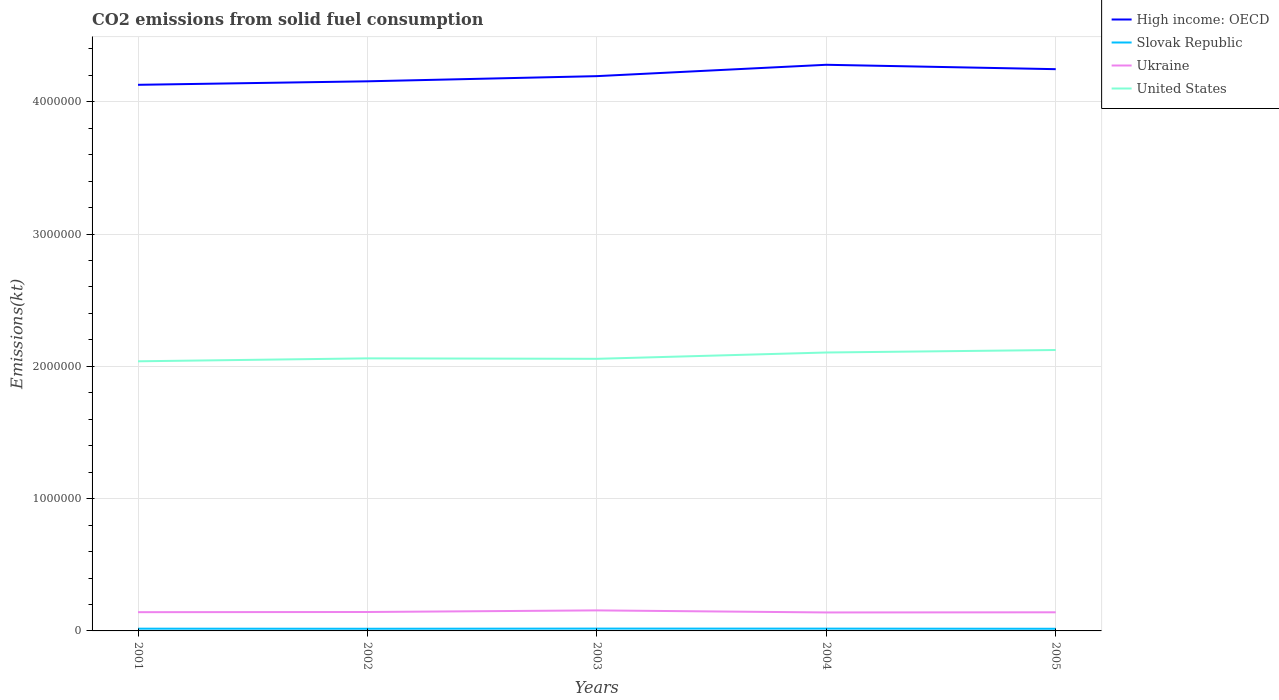Is the number of lines equal to the number of legend labels?
Give a very brief answer. Yes. Across all years, what is the maximum amount of CO2 emitted in Slovak Republic?
Your response must be concise. 1.63e+04. What is the total amount of CO2 emitted in High income: OECD in the graph?
Give a very brief answer. -2.64e+04. What is the difference between the highest and the second highest amount of CO2 emitted in Slovak Republic?
Ensure brevity in your answer.  1305.45. What is the difference between the highest and the lowest amount of CO2 emitted in Ukraine?
Make the answer very short. 1. Is the amount of CO2 emitted in United States strictly greater than the amount of CO2 emitted in Slovak Republic over the years?
Your answer should be compact. No. How many years are there in the graph?
Offer a very short reply. 5. What is the difference between two consecutive major ticks on the Y-axis?
Offer a terse response. 1.00e+06. Does the graph contain grids?
Provide a succinct answer. Yes. Where does the legend appear in the graph?
Your answer should be compact. Top right. How many legend labels are there?
Your answer should be very brief. 4. What is the title of the graph?
Provide a succinct answer. CO2 emissions from solid fuel consumption. What is the label or title of the Y-axis?
Your answer should be very brief. Emissions(kt). What is the Emissions(kt) of High income: OECD in 2001?
Provide a short and direct response. 4.13e+06. What is the Emissions(kt) in Slovak Republic in 2001?
Give a very brief answer. 1.70e+04. What is the Emissions(kt) in Ukraine in 2001?
Your answer should be very brief. 1.42e+05. What is the Emissions(kt) in United States in 2001?
Your answer should be compact. 2.04e+06. What is the Emissions(kt) in High income: OECD in 2002?
Your answer should be compact. 4.15e+06. What is the Emissions(kt) in Slovak Republic in 2002?
Offer a very short reply. 1.64e+04. What is the Emissions(kt) in Ukraine in 2002?
Offer a very short reply. 1.43e+05. What is the Emissions(kt) of United States in 2002?
Give a very brief answer. 2.06e+06. What is the Emissions(kt) of High income: OECD in 2003?
Make the answer very short. 4.19e+06. What is the Emissions(kt) in Slovak Republic in 2003?
Offer a very short reply. 1.76e+04. What is the Emissions(kt) of Ukraine in 2003?
Provide a succinct answer. 1.55e+05. What is the Emissions(kt) in United States in 2003?
Offer a very short reply. 2.06e+06. What is the Emissions(kt) in High income: OECD in 2004?
Your answer should be very brief. 4.28e+06. What is the Emissions(kt) in Slovak Republic in 2004?
Your response must be concise. 1.73e+04. What is the Emissions(kt) in Ukraine in 2004?
Offer a very short reply. 1.40e+05. What is the Emissions(kt) in United States in 2004?
Offer a terse response. 2.10e+06. What is the Emissions(kt) of High income: OECD in 2005?
Offer a terse response. 4.25e+06. What is the Emissions(kt) in Slovak Republic in 2005?
Your answer should be compact. 1.63e+04. What is the Emissions(kt) in Ukraine in 2005?
Provide a short and direct response. 1.41e+05. What is the Emissions(kt) of United States in 2005?
Make the answer very short. 2.12e+06. Across all years, what is the maximum Emissions(kt) of High income: OECD?
Your response must be concise. 4.28e+06. Across all years, what is the maximum Emissions(kt) of Slovak Republic?
Make the answer very short. 1.76e+04. Across all years, what is the maximum Emissions(kt) of Ukraine?
Give a very brief answer. 1.55e+05. Across all years, what is the maximum Emissions(kt) of United States?
Ensure brevity in your answer.  2.12e+06. Across all years, what is the minimum Emissions(kt) of High income: OECD?
Provide a succinct answer. 4.13e+06. Across all years, what is the minimum Emissions(kt) of Slovak Republic?
Keep it short and to the point. 1.63e+04. Across all years, what is the minimum Emissions(kt) in Ukraine?
Make the answer very short. 1.40e+05. Across all years, what is the minimum Emissions(kt) in United States?
Offer a terse response. 2.04e+06. What is the total Emissions(kt) of High income: OECD in the graph?
Make the answer very short. 2.10e+07. What is the total Emissions(kt) in Slovak Republic in the graph?
Your answer should be compact. 8.47e+04. What is the total Emissions(kt) in Ukraine in the graph?
Provide a succinct answer. 7.20e+05. What is the total Emissions(kt) in United States in the graph?
Provide a short and direct response. 1.04e+07. What is the difference between the Emissions(kt) in High income: OECD in 2001 and that in 2002?
Your answer should be compact. -2.64e+04. What is the difference between the Emissions(kt) in Slovak Republic in 2001 and that in 2002?
Provide a short and direct response. 557.38. What is the difference between the Emissions(kt) of Ukraine in 2001 and that in 2002?
Provide a short and direct response. -1279.78. What is the difference between the Emissions(kt) of United States in 2001 and that in 2002?
Provide a short and direct response. -2.22e+04. What is the difference between the Emissions(kt) in High income: OECD in 2001 and that in 2003?
Your answer should be very brief. -6.56e+04. What is the difference between the Emissions(kt) in Slovak Republic in 2001 and that in 2003?
Provide a succinct answer. -671.06. What is the difference between the Emissions(kt) of Ukraine in 2001 and that in 2003?
Your response must be concise. -1.35e+04. What is the difference between the Emissions(kt) of United States in 2001 and that in 2003?
Ensure brevity in your answer.  -1.88e+04. What is the difference between the Emissions(kt) in High income: OECD in 2001 and that in 2004?
Provide a short and direct response. -1.51e+05. What is the difference between the Emissions(kt) of Slovak Republic in 2001 and that in 2004?
Provide a succinct answer. -341.03. What is the difference between the Emissions(kt) of Ukraine in 2001 and that in 2004?
Provide a short and direct response. 2207.53. What is the difference between the Emissions(kt) of United States in 2001 and that in 2004?
Offer a terse response. -6.65e+04. What is the difference between the Emissions(kt) of High income: OECD in 2001 and that in 2005?
Your answer should be very brief. -1.18e+05. What is the difference between the Emissions(kt) of Slovak Republic in 2001 and that in 2005?
Offer a terse response. 634.39. What is the difference between the Emissions(kt) in Ukraine in 2001 and that in 2005?
Provide a succinct answer. 982.76. What is the difference between the Emissions(kt) in United States in 2001 and that in 2005?
Give a very brief answer. -8.54e+04. What is the difference between the Emissions(kt) of High income: OECD in 2002 and that in 2003?
Make the answer very short. -3.92e+04. What is the difference between the Emissions(kt) of Slovak Republic in 2002 and that in 2003?
Ensure brevity in your answer.  -1228.44. What is the difference between the Emissions(kt) in Ukraine in 2002 and that in 2003?
Keep it short and to the point. -1.22e+04. What is the difference between the Emissions(kt) of United States in 2002 and that in 2003?
Offer a very short reply. 3446.98. What is the difference between the Emissions(kt) in High income: OECD in 2002 and that in 2004?
Your answer should be very brief. -1.25e+05. What is the difference between the Emissions(kt) in Slovak Republic in 2002 and that in 2004?
Your answer should be very brief. -898.41. What is the difference between the Emissions(kt) in Ukraine in 2002 and that in 2004?
Offer a terse response. 3487.32. What is the difference between the Emissions(kt) of United States in 2002 and that in 2004?
Provide a short and direct response. -4.43e+04. What is the difference between the Emissions(kt) in High income: OECD in 2002 and that in 2005?
Offer a terse response. -9.18e+04. What is the difference between the Emissions(kt) in Slovak Republic in 2002 and that in 2005?
Provide a short and direct response. 77.01. What is the difference between the Emissions(kt) in Ukraine in 2002 and that in 2005?
Your answer should be very brief. 2262.54. What is the difference between the Emissions(kt) of United States in 2002 and that in 2005?
Offer a very short reply. -6.32e+04. What is the difference between the Emissions(kt) of High income: OECD in 2003 and that in 2004?
Give a very brief answer. -8.59e+04. What is the difference between the Emissions(kt) in Slovak Republic in 2003 and that in 2004?
Keep it short and to the point. 330.03. What is the difference between the Emissions(kt) in Ukraine in 2003 and that in 2004?
Your answer should be very brief. 1.57e+04. What is the difference between the Emissions(kt) of United States in 2003 and that in 2004?
Your response must be concise. -4.77e+04. What is the difference between the Emissions(kt) in High income: OECD in 2003 and that in 2005?
Your response must be concise. -5.26e+04. What is the difference between the Emissions(kt) of Slovak Republic in 2003 and that in 2005?
Provide a succinct answer. 1305.45. What is the difference between the Emissions(kt) of Ukraine in 2003 and that in 2005?
Offer a terse response. 1.45e+04. What is the difference between the Emissions(kt) of United States in 2003 and that in 2005?
Ensure brevity in your answer.  -6.67e+04. What is the difference between the Emissions(kt) in High income: OECD in 2004 and that in 2005?
Offer a terse response. 3.32e+04. What is the difference between the Emissions(kt) in Slovak Republic in 2004 and that in 2005?
Keep it short and to the point. 975.42. What is the difference between the Emissions(kt) of Ukraine in 2004 and that in 2005?
Offer a very short reply. -1224.78. What is the difference between the Emissions(kt) of United States in 2004 and that in 2005?
Give a very brief answer. -1.90e+04. What is the difference between the Emissions(kt) of High income: OECD in 2001 and the Emissions(kt) of Slovak Republic in 2002?
Make the answer very short. 4.11e+06. What is the difference between the Emissions(kt) in High income: OECD in 2001 and the Emissions(kt) in Ukraine in 2002?
Your response must be concise. 3.99e+06. What is the difference between the Emissions(kt) in High income: OECD in 2001 and the Emissions(kt) in United States in 2002?
Ensure brevity in your answer.  2.07e+06. What is the difference between the Emissions(kt) of Slovak Republic in 2001 and the Emissions(kt) of Ukraine in 2002?
Give a very brief answer. -1.26e+05. What is the difference between the Emissions(kt) in Slovak Republic in 2001 and the Emissions(kt) in United States in 2002?
Give a very brief answer. -2.04e+06. What is the difference between the Emissions(kt) in Ukraine in 2001 and the Emissions(kt) in United States in 2002?
Make the answer very short. -1.92e+06. What is the difference between the Emissions(kt) in High income: OECD in 2001 and the Emissions(kt) in Slovak Republic in 2003?
Your answer should be very brief. 4.11e+06. What is the difference between the Emissions(kt) in High income: OECD in 2001 and the Emissions(kt) in Ukraine in 2003?
Make the answer very short. 3.97e+06. What is the difference between the Emissions(kt) of High income: OECD in 2001 and the Emissions(kt) of United States in 2003?
Your answer should be very brief. 2.07e+06. What is the difference between the Emissions(kt) in Slovak Republic in 2001 and the Emissions(kt) in Ukraine in 2003?
Your answer should be very brief. -1.38e+05. What is the difference between the Emissions(kt) in Slovak Republic in 2001 and the Emissions(kt) in United States in 2003?
Ensure brevity in your answer.  -2.04e+06. What is the difference between the Emissions(kt) in Ukraine in 2001 and the Emissions(kt) in United States in 2003?
Ensure brevity in your answer.  -1.92e+06. What is the difference between the Emissions(kt) in High income: OECD in 2001 and the Emissions(kt) in Slovak Republic in 2004?
Give a very brief answer. 4.11e+06. What is the difference between the Emissions(kt) of High income: OECD in 2001 and the Emissions(kt) of Ukraine in 2004?
Keep it short and to the point. 3.99e+06. What is the difference between the Emissions(kt) of High income: OECD in 2001 and the Emissions(kt) of United States in 2004?
Your answer should be very brief. 2.02e+06. What is the difference between the Emissions(kt) in Slovak Republic in 2001 and the Emissions(kt) in Ukraine in 2004?
Ensure brevity in your answer.  -1.23e+05. What is the difference between the Emissions(kt) in Slovak Republic in 2001 and the Emissions(kt) in United States in 2004?
Your answer should be compact. -2.09e+06. What is the difference between the Emissions(kt) of Ukraine in 2001 and the Emissions(kt) of United States in 2004?
Give a very brief answer. -1.96e+06. What is the difference between the Emissions(kt) of High income: OECD in 2001 and the Emissions(kt) of Slovak Republic in 2005?
Make the answer very short. 4.11e+06. What is the difference between the Emissions(kt) of High income: OECD in 2001 and the Emissions(kt) of Ukraine in 2005?
Make the answer very short. 3.99e+06. What is the difference between the Emissions(kt) in High income: OECD in 2001 and the Emissions(kt) in United States in 2005?
Your answer should be very brief. 2.00e+06. What is the difference between the Emissions(kt) of Slovak Republic in 2001 and the Emissions(kt) of Ukraine in 2005?
Your answer should be compact. -1.24e+05. What is the difference between the Emissions(kt) of Slovak Republic in 2001 and the Emissions(kt) of United States in 2005?
Your answer should be very brief. -2.11e+06. What is the difference between the Emissions(kt) in Ukraine in 2001 and the Emissions(kt) in United States in 2005?
Offer a very short reply. -1.98e+06. What is the difference between the Emissions(kt) of High income: OECD in 2002 and the Emissions(kt) of Slovak Republic in 2003?
Your answer should be compact. 4.14e+06. What is the difference between the Emissions(kt) in High income: OECD in 2002 and the Emissions(kt) in Ukraine in 2003?
Give a very brief answer. 4.00e+06. What is the difference between the Emissions(kt) in High income: OECD in 2002 and the Emissions(kt) in United States in 2003?
Provide a short and direct response. 2.10e+06. What is the difference between the Emissions(kt) of Slovak Republic in 2002 and the Emissions(kt) of Ukraine in 2003?
Your answer should be very brief. -1.39e+05. What is the difference between the Emissions(kt) of Slovak Republic in 2002 and the Emissions(kt) of United States in 2003?
Provide a short and direct response. -2.04e+06. What is the difference between the Emissions(kt) of Ukraine in 2002 and the Emissions(kt) of United States in 2003?
Give a very brief answer. -1.91e+06. What is the difference between the Emissions(kt) in High income: OECD in 2002 and the Emissions(kt) in Slovak Republic in 2004?
Make the answer very short. 4.14e+06. What is the difference between the Emissions(kt) of High income: OECD in 2002 and the Emissions(kt) of Ukraine in 2004?
Offer a terse response. 4.01e+06. What is the difference between the Emissions(kt) of High income: OECD in 2002 and the Emissions(kt) of United States in 2004?
Offer a terse response. 2.05e+06. What is the difference between the Emissions(kt) of Slovak Republic in 2002 and the Emissions(kt) of Ukraine in 2004?
Your answer should be compact. -1.23e+05. What is the difference between the Emissions(kt) in Slovak Republic in 2002 and the Emissions(kt) in United States in 2004?
Make the answer very short. -2.09e+06. What is the difference between the Emissions(kt) of Ukraine in 2002 and the Emissions(kt) of United States in 2004?
Keep it short and to the point. -1.96e+06. What is the difference between the Emissions(kt) of High income: OECD in 2002 and the Emissions(kt) of Slovak Republic in 2005?
Your answer should be compact. 4.14e+06. What is the difference between the Emissions(kt) in High income: OECD in 2002 and the Emissions(kt) in Ukraine in 2005?
Provide a succinct answer. 4.01e+06. What is the difference between the Emissions(kt) in High income: OECD in 2002 and the Emissions(kt) in United States in 2005?
Keep it short and to the point. 2.03e+06. What is the difference between the Emissions(kt) of Slovak Republic in 2002 and the Emissions(kt) of Ukraine in 2005?
Your answer should be very brief. -1.24e+05. What is the difference between the Emissions(kt) in Slovak Republic in 2002 and the Emissions(kt) in United States in 2005?
Provide a succinct answer. -2.11e+06. What is the difference between the Emissions(kt) in Ukraine in 2002 and the Emissions(kt) in United States in 2005?
Offer a terse response. -1.98e+06. What is the difference between the Emissions(kt) in High income: OECD in 2003 and the Emissions(kt) in Slovak Republic in 2004?
Ensure brevity in your answer.  4.18e+06. What is the difference between the Emissions(kt) of High income: OECD in 2003 and the Emissions(kt) of Ukraine in 2004?
Provide a short and direct response. 4.05e+06. What is the difference between the Emissions(kt) of High income: OECD in 2003 and the Emissions(kt) of United States in 2004?
Keep it short and to the point. 2.09e+06. What is the difference between the Emissions(kt) of Slovak Republic in 2003 and the Emissions(kt) of Ukraine in 2004?
Give a very brief answer. -1.22e+05. What is the difference between the Emissions(kt) of Slovak Republic in 2003 and the Emissions(kt) of United States in 2004?
Give a very brief answer. -2.09e+06. What is the difference between the Emissions(kt) of Ukraine in 2003 and the Emissions(kt) of United States in 2004?
Provide a short and direct response. -1.95e+06. What is the difference between the Emissions(kt) in High income: OECD in 2003 and the Emissions(kt) in Slovak Republic in 2005?
Offer a very short reply. 4.18e+06. What is the difference between the Emissions(kt) in High income: OECD in 2003 and the Emissions(kt) in Ukraine in 2005?
Make the answer very short. 4.05e+06. What is the difference between the Emissions(kt) of High income: OECD in 2003 and the Emissions(kt) of United States in 2005?
Your response must be concise. 2.07e+06. What is the difference between the Emissions(kt) of Slovak Republic in 2003 and the Emissions(kt) of Ukraine in 2005?
Ensure brevity in your answer.  -1.23e+05. What is the difference between the Emissions(kt) of Slovak Republic in 2003 and the Emissions(kt) of United States in 2005?
Give a very brief answer. -2.11e+06. What is the difference between the Emissions(kt) in Ukraine in 2003 and the Emissions(kt) in United States in 2005?
Your answer should be very brief. -1.97e+06. What is the difference between the Emissions(kt) of High income: OECD in 2004 and the Emissions(kt) of Slovak Republic in 2005?
Provide a short and direct response. 4.26e+06. What is the difference between the Emissions(kt) of High income: OECD in 2004 and the Emissions(kt) of Ukraine in 2005?
Your answer should be compact. 4.14e+06. What is the difference between the Emissions(kt) in High income: OECD in 2004 and the Emissions(kt) in United States in 2005?
Your answer should be very brief. 2.16e+06. What is the difference between the Emissions(kt) of Slovak Republic in 2004 and the Emissions(kt) of Ukraine in 2005?
Ensure brevity in your answer.  -1.23e+05. What is the difference between the Emissions(kt) of Slovak Republic in 2004 and the Emissions(kt) of United States in 2005?
Your answer should be compact. -2.11e+06. What is the difference between the Emissions(kt) of Ukraine in 2004 and the Emissions(kt) of United States in 2005?
Provide a succinct answer. -1.98e+06. What is the average Emissions(kt) in High income: OECD per year?
Your answer should be compact. 4.20e+06. What is the average Emissions(kt) in Slovak Republic per year?
Keep it short and to the point. 1.69e+04. What is the average Emissions(kt) in Ukraine per year?
Ensure brevity in your answer.  1.44e+05. What is the average Emissions(kt) of United States per year?
Offer a very short reply. 2.08e+06. In the year 2001, what is the difference between the Emissions(kt) of High income: OECD and Emissions(kt) of Slovak Republic?
Give a very brief answer. 4.11e+06. In the year 2001, what is the difference between the Emissions(kt) in High income: OECD and Emissions(kt) in Ukraine?
Your answer should be compact. 3.99e+06. In the year 2001, what is the difference between the Emissions(kt) in High income: OECD and Emissions(kt) in United States?
Your answer should be compact. 2.09e+06. In the year 2001, what is the difference between the Emissions(kt) in Slovak Republic and Emissions(kt) in Ukraine?
Ensure brevity in your answer.  -1.25e+05. In the year 2001, what is the difference between the Emissions(kt) of Slovak Republic and Emissions(kt) of United States?
Provide a short and direct response. -2.02e+06. In the year 2001, what is the difference between the Emissions(kt) in Ukraine and Emissions(kt) in United States?
Ensure brevity in your answer.  -1.90e+06. In the year 2002, what is the difference between the Emissions(kt) in High income: OECD and Emissions(kt) in Slovak Republic?
Ensure brevity in your answer.  4.14e+06. In the year 2002, what is the difference between the Emissions(kt) in High income: OECD and Emissions(kt) in Ukraine?
Provide a succinct answer. 4.01e+06. In the year 2002, what is the difference between the Emissions(kt) of High income: OECD and Emissions(kt) of United States?
Your response must be concise. 2.09e+06. In the year 2002, what is the difference between the Emissions(kt) in Slovak Republic and Emissions(kt) in Ukraine?
Make the answer very short. -1.27e+05. In the year 2002, what is the difference between the Emissions(kt) in Slovak Republic and Emissions(kt) in United States?
Offer a very short reply. -2.04e+06. In the year 2002, what is the difference between the Emissions(kt) of Ukraine and Emissions(kt) of United States?
Your answer should be very brief. -1.92e+06. In the year 2003, what is the difference between the Emissions(kt) of High income: OECD and Emissions(kt) of Slovak Republic?
Your answer should be very brief. 4.18e+06. In the year 2003, what is the difference between the Emissions(kt) in High income: OECD and Emissions(kt) in Ukraine?
Offer a terse response. 4.04e+06. In the year 2003, what is the difference between the Emissions(kt) in High income: OECD and Emissions(kt) in United States?
Make the answer very short. 2.14e+06. In the year 2003, what is the difference between the Emissions(kt) of Slovak Republic and Emissions(kt) of Ukraine?
Give a very brief answer. -1.38e+05. In the year 2003, what is the difference between the Emissions(kt) of Slovak Republic and Emissions(kt) of United States?
Provide a short and direct response. -2.04e+06. In the year 2003, what is the difference between the Emissions(kt) of Ukraine and Emissions(kt) of United States?
Your response must be concise. -1.90e+06. In the year 2004, what is the difference between the Emissions(kt) in High income: OECD and Emissions(kt) in Slovak Republic?
Your answer should be compact. 4.26e+06. In the year 2004, what is the difference between the Emissions(kt) of High income: OECD and Emissions(kt) of Ukraine?
Provide a short and direct response. 4.14e+06. In the year 2004, what is the difference between the Emissions(kt) of High income: OECD and Emissions(kt) of United States?
Your answer should be very brief. 2.17e+06. In the year 2004, what is the difference between the Emissions(kt) of Slovak Republic and Emissions(kt) of Ukraine?
Provide a succinct answer. -1.22e+05. In the year 2004, what is the difference between the Emissions(kt) in Slovak Republic and Emissions(kt) in United States?
Keep it short and to the point. -2.09e+06. In the year 2004, what is the difference between the Emissions(kt) in Ukraine and Emissions(kt) in United States?
Your answer should be very brief. -1.97e+06. In the year 2005, what is the difference between the Emissions(kt) of High income: OECD and Emissions(kt) of Slovak Republic?
Ensure brevity in your answer.  4.23e+06. In the year 2005, what is the difference between the Emissions(kt) in High income: OECD and Emissions(kt) in Ukraine?
Give a very brief answer. 4.11e+06. In the year 2005, what is the difference between the Emissions(kt) in High income: OECD and Emissions(kt) in United States?
Make the answer very short. 2.12e+06. In the year 2005, what is the difference between the Emissions(kt) in Slovak Republic and Emissions(kt) in Ukraine?
Provide a succinct answer. -1.24e+05. In the year 2005, what is the difference between the Emissions(kt) of Slovak Republic and Emissions(kt) of United States?
Provide a succinct answer. -2.11e+06. In the year 2005, what is the difference between the Emissions(kt) in Ukraine and Emissions(kt) in United States?
Your response must be concise. -1.98e+06. What is the ratio of the Emissions(kt) in Slovak Republic in 2001 to that in 2002?
Ensure brevity in your answer.  1.03. What is the ratio of the Emissions(kt) in Ukraine in 2001 to that in 2002?
Ensure brevity in your answer.  0.99. What is the ratio of the Emissions(kt) of High income: OECD in 2001 to that in 2003?
Make the answer very short. 0.98. What is the ratio of the Emissions(kt) in Ukraine in 2001 to that in 2003?
Ensure brevity in your answer.  0.91. What is the ratio of the Emissions(kt) in United States in 2001 to that in 2003?
Ensure brevity in your answer.  0.99. What is the ratio of the Emissions(kt) of High income: OECD in 2001 to that in 2004?
Make the answer very short. 0.96. What is the ratio of the Emissions(kt) of Slovak Republic in 2001 to that in 2004?
Provide a succinct answer. 0.98. What is the ratio of the Emissions(kt) in Ukraine in 2001 to that in 2004?
Keep it short and to the point. 1.02. What is the ratio of the Emissions(kt) in United States in 2001 to that in 2004?
Provide a succinct answer. 0.97. What is the ratio of the Emissions(kt) in High income: OECD in 2001 to that in 2005?
Your answer should be very brief. 0.97. What is the ratio of the Emissions(kt) of Slovak Republic in 2001 to that in 2005?
Offer a very short reply. 1.04. What is the ratio of the Emissions(kt) in Ukraine in 2001 to that in 2005?
Ensure brevity in your answer.  1.01. What is the ratio of the Emissions(kt) in United States in 2001 to that in 2005?
Your answer should be very brief. 0.96. What is the ratio of the Emissions(kt) in High income: OECD in 2002 to that in 2003?
Provide a short and direct response. 0.99. What is the ratio of the Emissions(kt) of Slovak Republic in 2002 to that in 2003?
Provide a short and direct response. 0.93. What is the ratio of the Emissions(kt) of Ukraine in 2002 to that in 2003?
Provide a succinct answer. 0.92. What is the ratio of the Emissions(kt) in High income: OECD in 2002 to that in 2004?
Provide a succinct answer. 0.97. What is the ratio of the Emissions(kt) in Slovak Republic in 2002 to that in 2004?
Keep it short and to the point. 0.95. What is the ratio of the Emissions(kt) of United States in 2002 to that in 2004?
Your response must be concise. 0.98. What is the ratio of the Emissions(kt) in High income: OECD in 2002 to that in 2005?
Offer a very short reply. 0.98. What is the ratio of the Emissions(kt) in Slovak Republic in 2002 to that in 2005?
Your answer should be very brief. 1. What is the ratio of the Emissions(kt) in Ukraine in 2002 to that in 2005?
Offer a very short reply. 1.02. What is the ratio of the Emissions(kt) in United States in 2002 to that in 2005?
Keep it short and to the point. 0.97. What is the ratio of the Emissions(kt) of High income: OECD in 2003 to that in 2004?
Provide a succinct answer. 0.98. What is the ratio of the Emissions(kt) in Slovak Republic in 2003 to that in 2004?
Your answer should be very brief. 1.02. What is the ratio of the Emissions(kt) in Ukraine in 2003 to that in 2004?
Give a very brief answer. 1.11. What is the ratio of the Emissions(kt) in United States in 2003 to that in 2004?
Provide a short and direct response. 0.98. What is the ratio of the Emissions(kt) of High income: OECD in 2003 to that in 2005?
Provide a succinct answer. 0.99. What is the ratio of the Emissions(kt) in Slovak Republic in 2003 to that in 2005?
Your answer should be compact. 1.08. What is the ratio of the Emissions(kt) in Ukraine in 2003 to that in 2005?
Offer a terse response. 1.1. What is the ratio of the Emissions(kt) in United States in 2003 to that in 2005?
Make the answer very short. 0.97. What is the ratio of the Emissions(kt) of High income: OECD in 2004 to that in 2005?
Offer a very short reply. 1.01. What is the ratio of the Emissions(kt) of Slovak Republic in 2004 to that in 2005?
Provide a short and direct response. 1.06. What is the ratio of the Emissions(kt) of Ukraine in 2004 to that in 2005?
Give a very brief answer. 0.99. What is the difference between the highest and the second highest Emissions(kt) of High income: OECD?
Provide a short and direct response. 3.32e+04. What is the difference between the highest and the second highest Emissions(kt) of Slovak Republic?
Your answer should be very brief. 330.03. What is the difference between the highest and the second highest Emissions(kt) of Ukraine?
Offer a very short reply. 1.22e+04. What is the difference between the highest and the second highest Emissions(kt) of United States?
Provide a short and direct response. 1.90e+04. What is the difference between the highest and the lowest Emissions(kt) in High income: OECD?
Make the answer very short. 1.51e+05. What is the difference between the highest and the lowest Emissions(kt) of Slovak Republic?
Keep it short and to the point. 1305.45. What is the difference between the highest and the lowest Emissions(kt) of Ukraine?
Provide a succinct answer. 1.57e+04. What is the difference between the highest and the lowest Emissions(kt) of United States?
Your answer should be very brief. 8.54e+04. 